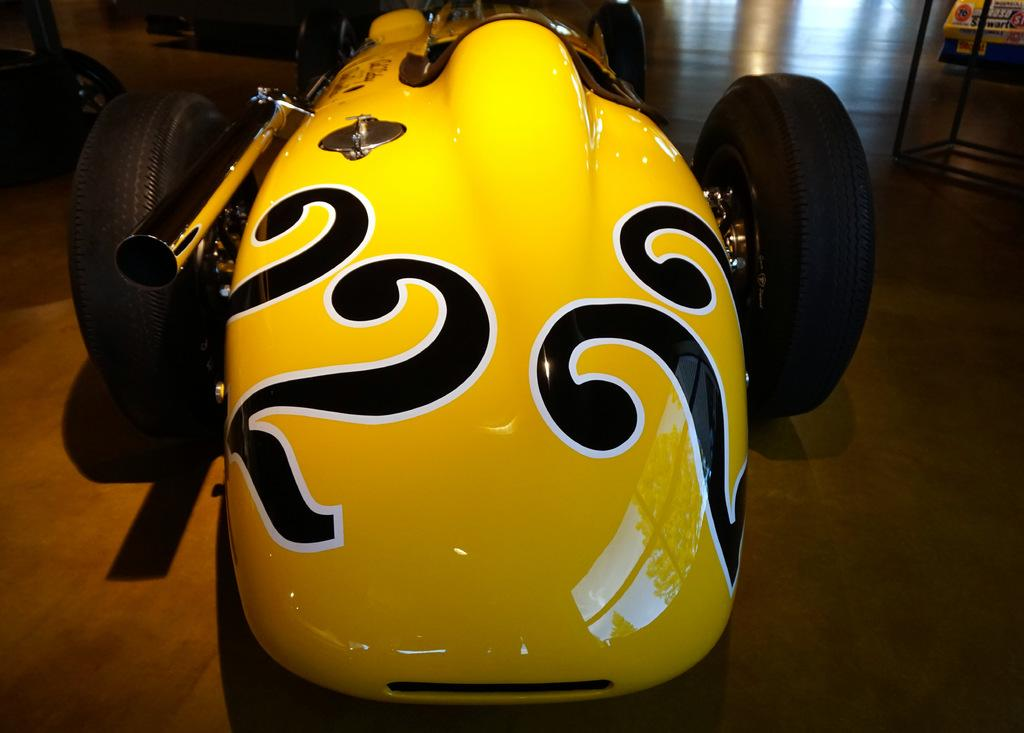What color is the vehicle in the image? The vehicle in the image is yellow. Are there any other vehicles visible in the image? Yes, there are other vehicles visible in the background of the image. Where are the vehicles located in the image? The vehicles are on the floor. Can you see a crow sitting on the yellow vehicle in the image? There is no crow present in the image. 